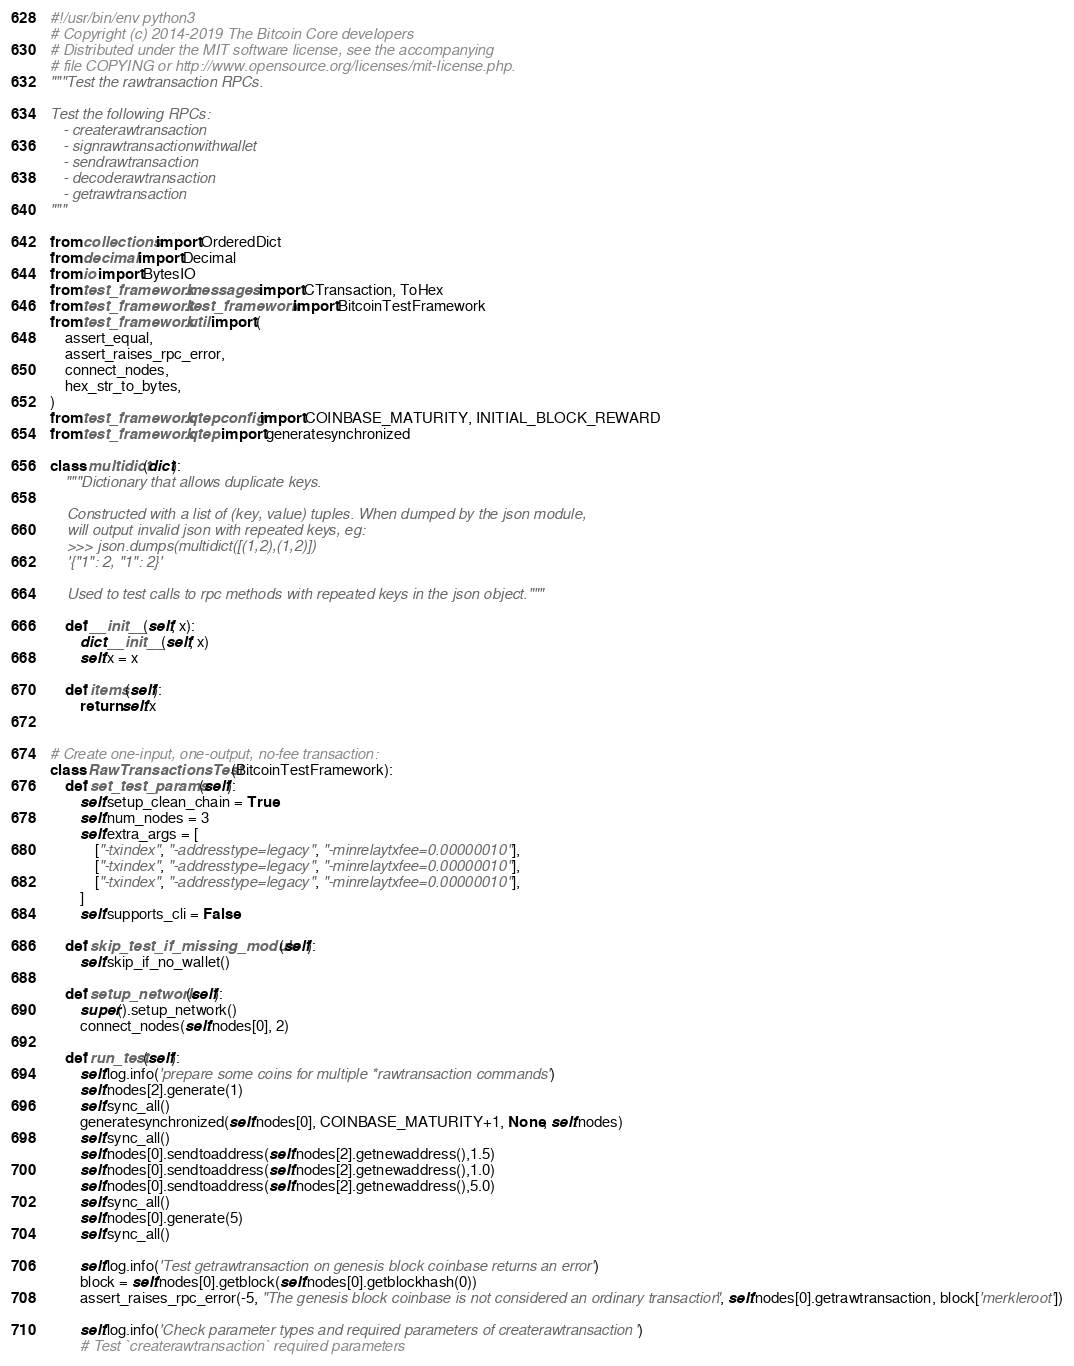Convert code to text. <code><loc_0><loc_0><loc_500><loc_500><_Python_>#!/usr/bin/env python3
# Copyright (c) 2014-2019 The Bitcoin Core developers
# Distributed under the MIT software license, see the accompanying
# file COPYING or http://www.opensource.org/licenses/mit-license.php.
"""Test the rawtransaction RPCs.

Test the following RPCs:
   - createrawtransaction
   - signrawtransactionwithwallet
   - sendrawtransaction
   - decoderawtransaction
   - getrawtransaction
"""

from collections import OrderedDict
from decimal import Decimal
from io import BytesIO
from test_framework.messages import CTransaction, ToHex
from test_framework.test_framework import BitcoinTestFramework
from test_framework.util import (
    assert_equal,
    assert_raises_rpc_error,
    connect_nodes,
    hex_str_to_bytes,
)
from test_framework.qtepconfig import COINBASE_MATURITY, INITIAL_BLOCK_REWARD
from test_framework.qtep import generatesynchronized

class multidict(dict):
    """Dictionary that allows duplicate keys.

    Constructed with a list of (key, value) tuples. When dumped by the json module,
    will output invalid json with repeated keys, eg:
    >>> json.dumps(multidict([(1,2),(1,2)])
    '{"1": 2, "1": 2}'

    Used to test calls to rpc methods with repeated keys in the json object."""

    def __init__(self, x):
        dict.__init__(self, x)
        self.x = x

    def items(self):
        return self.x


# Create one-input, one-output, no-fee transaction:
class RawTransactionsTest(BitcoinTestFramework):
    def set_test_params(self):
        self.setup_clean_chain = True
        self.num_nodes = 3
        self.extra_args = [
            ["-txindex", "-addresstype=legacy", "-minrelaytxfee=0.00000010"],
            ["-txindex", "-addresstype=legacy", "-minrelaytxfee=0.00000010"],
            ["-txindex", "-addresstype=legacy", "-minrelaytxfee=0.00000010"],
        ]
        self.supports_cli = False

    def skip_test_if_missing_module(self):
        self.skip_if_no_wallet()

    def setup_network(self):
        super().setup_network()
        connect_nodes(self.nodes[0], 2)

    def run_test(self):
        self.log.info('prepare some coins for multiple *rawtransaction commands')
        self.nodes[2].generate(1)
        self.sync_all()
        generatesynchronized(self.nodes[0], COINBASE_MATURITY+1, None, self.nodes)
        self.sync_all()
        self.nodes[0].sendtoaddress(self.nodes[2].getnewaddress(),1.5)
        self.nodes[0].sendtoaddress(self.nodes[2].getnewaddress(),1.0)
        self.nodes[0].sendtoaddress(self.nodes[2].getnewaddress(),5.0)
        self.sync_all()
        self.nodes[0].generate(5)
        self.sync_all()

        self.log.info('Test getrawtransaction on genesis block coinbase returns an error')
        block = self.nodes[0].getblock(self.nodes[0].getblockhash(0))
        assert_raises_rpc_error(-5, "The genesis block coinbase is not considered an ordinary transaction", self.nodes[0].getrawtransaction, block['merkleroot'])

        self.log.info('Check parameter types and required parameters of createrawtransaction')
        # Test `createrawtransaction` required parameters</code> 